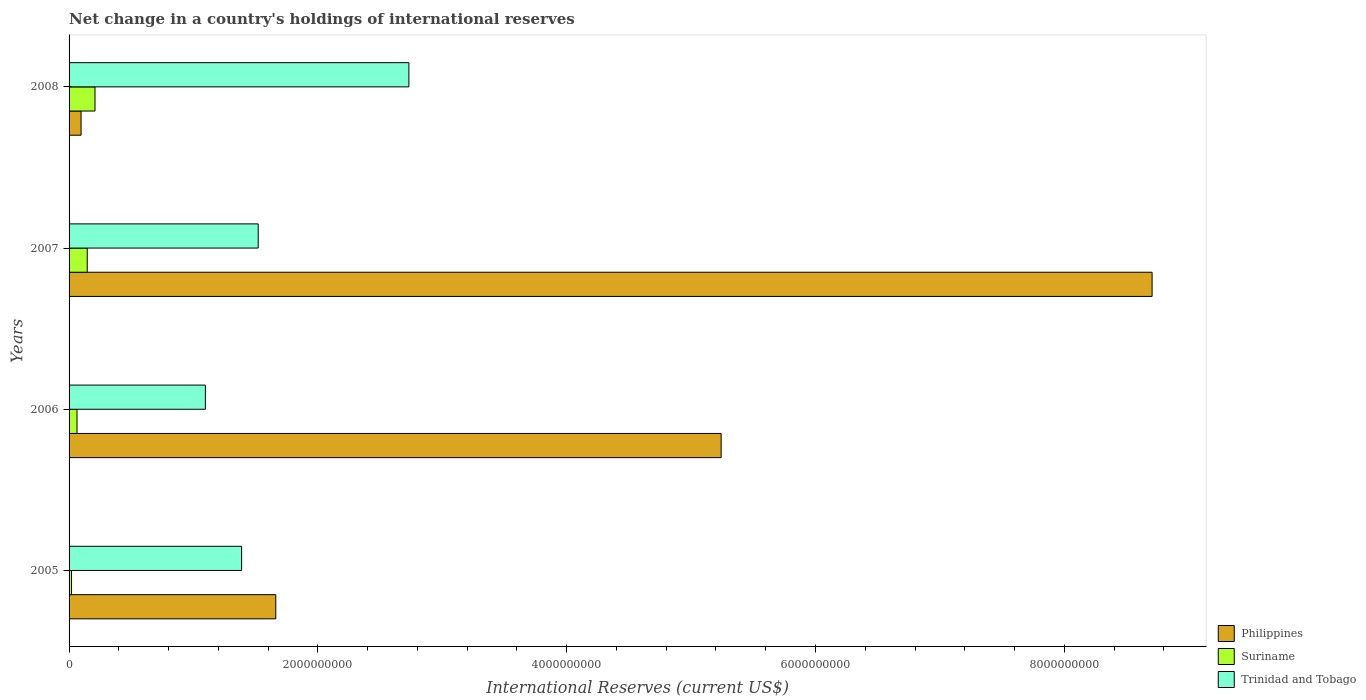How many different coloured bars are there?
Provide a short and direct response. 3. How many groups of bars are there?
Keep it short and to the point. 4. Are the number of bars per tick equal to the number of legend labels?
Offer a terse response. Yes. Are the number of bars on each tick of the Y-axis equal?
Provide a succinct answer. Yes. How many bars are there on the 1st tick from the bottom?
Keep it short and to the point. 3. What is the label of the 2nd group of bars from the top?
Your answer should be compact. 2007. In how many cases, is the number of bars for a given year not equal to the number of legend labels?
Give a very brief answer. 0. What is the international reserves in Suriname in 2007?
Keep it short and to the point. 1.46e+08. Across all years, what is the maximum international reserves in Philippines?
Your answer should be compact. 8.71e+09. Across all years, what is the minimum international reserves in Suriname?
Your answer should be very brief. 1.97e+07. In which year was the international reserves in Suriname maximum?
Provide a succinct answer. 2008. What is the total international reserves in Trinidad and Tobago in the graph?
Your response must be concise. 6.73e+09. What is the difference between the international reserves in Suriname in 2006 and that in 2007?
Your answer should be very brief. -8.22e+07. What is the difference between the international reserves in Suriname in 2005 and the international reserves in Trinidad and Tobago in 2008?
Ensure brevity in your answer.  -2.71e+09. What is the average international reserves in Suriname per year?
Ensure brevity in your answer.  1.10e+08. In the year 2006, what is the difference between the international reserves in Trinidad and Tobago and international reserves in Suriname?
Provide a short and direct response. 1.03e+09. In how many years, is the international reserves in Trinidad and Tobago greater than 5600000000 US$?
Offer a terse response. 0. What is the ratio of the international reserves in Philippines in 2007 to that in 2008?
Offer a terse response. 90.24. What is the difference between the highest and the second highest international reserves in Trinidad and Tobago?
Give a very brief answer. 1.21e+09. What is the difference between the highest and the lowest international reserves in Philippines?
Give a very brief answer. 8.61e+09. In how many years, is the international reserves in Philippines greater than the average international reserves in Philippines taken over all years?
Provide a short and direct response. 2. Is the sum of the international reserves in Suriname in 2005 and 2007 greater than the maximum international reserves in Philippines across all years?
Your answer should be very brief. No. What does the 1st bar from the top in 2007 represents?
Give a very brief answer. Trinidad and Tobago. Is it the case that in every year, the sum of the international reserves in Trinidad and Tobago and international reserves in Suriname is greater than the international reserves in Philippines?
Give a very brief answer. No. Are all the bars in the graph horizontal?
Make the answer very short. Yes. Are the values on the major ticks of X-axis written in scientific E-notation?
Ensure brevity in your answer.  No. Does the graph contain any zero values?
Provide a short and direct response. No. Does the graph contain grids?
Ensure brevity in your answer.  No. How are the legend labels stacked?
Keep it short and to the point. Vertical. What is the title of the graph?
Give a very brief answer. Net change in a country's holdings of international reserves. What is the label or title of the X-axis?
Ensure brevity in your answer.  International Reserves (current US$). What is the label or title of the Y-axis?
Make the answer very short. Years. What is the International Reserves (current US$) in Philippines in 2005?
Your answer should be compact. 1.66e+09. What is the International Reserves (current US$) of Suriname in 2005?
Provide a succinct answer. 1.97e+07. What is the International Reserves (current US$) of Trinidad and Tobago in 2005?
Your answer should be very brief. 1.39e+09. What is the International Reserves (current US$) in Philippines in 2006?
Offer a terse response. 5.24e+09. What is the International Reserves (current US$) of Suriname in 2006?
Offer a very short reply. 6.39e+07. What is the International Reserves (current US$) in Trinidad and Tobago in 2006?
Your response must be concise. 1.10e+09. What is the International Reserves (current US$) of Philippines in 2007?
Provide a succinct answer. 8.71e+09. What is the International Reserves (current US$) in Suriname in 2007?
Offer a very short reply. 1.46e+08. What is the International Reserves (current US$) of Trinidad and Tobago in 2007?
Make the answer very short. 1.52e+09. What is the International Reserves (current US$) in Philippines in 2008?
Your response must be concise. 9.65e+07. What is the International Reserves (current US$) of Suriname in 2008?
Your answer should be compact. 2.08e+08. What is the International Reserves (current US$) in Trinidad and Tobago in 2008?
Your answer should be compact. 2.73e+09. Across all years, what is the maximum International Reserves (current US$) of Philippines?
Offer a very short reply. 8.71e+09. Across all years, what is the maximum International Reserves (current US$) in Suriname?
Your answer should be very brief. 2.08e+08. Across all years, what is the maximum International Reserves (current US$) in Trinidad and Tobago?
Your answer should be very brief. 2.73e+09. Across all years, what is the minimum International Reserves (current US$) of Philippines?
Your answer should be compact. 9.65e+07. Across all years, what is the minimum International Reserves (current US$) of Suriname?
Provide a short and direct response. 1.97e+07. Across all years, what is the minimum International Reserves (current US$) of Trinidad and Tobago?
Your answer should be compact. 1.10e+09. What is the total International Reserves (current US$) in Philippines in the graph?
Keep it short and to the point. 1.57e+1. What is the total International Reserves (current US$) in Suriname in the graph?
Your answer should be very brief. 4.38e+08. What is the total International Reserves (current US$) of Trinidad and Tobago in the graph?
Make the answer very short. 6.73e+09. What is the difference between the International Reserves (current US$) in Philippines in 2005 and that in 2006?
Ensure brevity in your answer.  -3.58e+09. What is the difference between the International Reserves (current US$) of Suriname in 2005 and that in 2006?
Give a very brief answer. -4.42e+07. What is the difference between the International Reserves (current US$) of Trinidad and Tobago in 2005 and that in 2006?
Keep it short and to the point. 2.91e+08. What is the difference between the International Reserves (current US$) of Philippines in 2005 and that in 2007?
Your answer should be compact. -7.04e+09. What is the difference between the International Reserves (current US$) in Suriname in 2005 and that in 2007?
Offer a very short reply. -1.26e+08. What is the difference between the International Reserves (current US$) in Trinidad and Tobago in 2005 and that in 2007?
Provide a short and direct response. -1.33e+08. What is the difference between the International Reserves (current US$) of Philippines in 2005 and that in 2008?
Your answer should be very brief. 1.57e+09. What is the difference between the International Reserves (current US$) of Suriname in 2005 and that in 2008?
Ensure brevity in your answer.  -1.89e+08. What is the difference between the International Reserves (current US$) in Trinidad and Tobago in 2005 and that in 2008?
Offer a very short reply. -1.34e+09. What is the difference between the International Reserves (current US$) in Philippines in 2006 and that in 2007?
Ensure brevity in your answer.  -3.46e+09. What is the difference between the International Reserves (current US$) in Suriname in 2006 and that in 2007?
Offer a terse response. -8.22e+07. What is the difference between the International Reserves (current US$) of Trinidad and Tobago in 2006 and that in 2007?
Your response must be concise. -4.25e+08. What is the difference between the International Reserves (current US$) in Philippines in 2006 and that in 2008?
Offer a very short reply. 5.15e+09. What is the difference between the International Reserves (current US$) of Suriname in 2006 and that in 2008?
Offer a terse response. -1.44e+08. What is the difference between the International Reserves (current US$) in Trinidad and Tobago in 2006 and that in 2008?
Offer a very short reply. -1.64e+09. What is the difference between the International Reserves (current US$) in Philippines in 2007 and that in 2008?
Your answer should be compact. 8.61e+09. What is the difference between the International Reserves (current US$) in Suriname in 2007 and that in 2008?
Your answer should be compact. -6.23e+07. What is the difference between the International Reserves (current US$) in Trinidad and Tobago in 2007 and that in 2008?
Offer a terse response. -1.21e+09. What is the difference between the International Reserves (current US$) in Philippines in 2005 and the International Reserves (current US$) in Suriname in 2006?
Ensure brevity in your answer.  1.60e+09. What is the difference between the International Reserves (current US$) of Philippines in 2005 and the International Reserves (current US$) of Trinidad and Tobago in 2006?
Your response must be concise. 5.66e+08. What is the difference between the International Reserves (current US$) in Suriname in 2005 and the International Reserves (current US$) in Trinidad and Tobago in 2006?
Keep it short and to the point. -1.08e+09. What is the difference between the International Reserves (current US$) of Philippines in 2005 and the International Reserves (current US$) of Suriname in 2007?
Make the answer very short. 1.52e+09. What is the difference between the International Reserves (current US$) in Philippines in 2005 and the International Reserves (current US$) in Trinidad and Tobago in 2007?
Your answer should be very brief. 1.41e+08. What is the difference between the International Reserves (current US$) of Suriname in 2005 and the International Reserves (current US$) of Trinidad and Tobago in 2007?
Provide a short and direct response. -1.50e+09. What is the difference between the International Reserves (current US$) in Philippines in 2005 and the International Reserves (current US$) in Suriname in 2008?
Your answer should be compact. 1.45e+09. What is the difference between the International Reserves (current US$) of Philippines in 2005 and the International Reserves (current US$) of Trinidad and Tobago in 2008?
Your answer should be compact. -1.07e+09. What is the difference between the International Reserves (current US$) of Suriname in 2005 and the International Reserves (current US$) of Trinidad and Tobago in 2008?
Your answer should be very brief. -2.71e+09. What is the difference between the International Reserves (current US$) in Philippines in 2006 and the International Reserves (current US$) in Suriname in 2007?
Offer a very short reply. 5.10e+09. What is the difference between the International Reserves (current US$) of Philippines in 2006 and the International Reserves (current US$) of Trinidad and Tobago in 2007?
Provide a succinct answer. 3.72e+09. What is the difference between the International Reserves (current US$) in Suriname in 2006 and the International Reserves (current US$) in Trinidad and Tobago in 2007?
Provide a short and direct response. -1.46e+09. What is the difference between the International Reserves (current US$) in Philippines in 2006 and the International Reserves (current US$) in Suriname in 2008?
Offer a terse response. 5.03e+09. What is the difference between the International Reserves (current US$) in Philippines in 2006 and the International Reserves (current US$) in Trinidad and Tobago in 2008?
Make the answer very short. 2.51e+09. What is the difference between the International Reserves (current US$) of Suriname in 2006 and the International Reserves (current US$) of Trinidad and Tobago in 2008?
Make the answer very short. -2.67e+09. What is the difference between the International Reserves (current US$) of Philippines in 2007 and the International Reserves (current US$) of Suriname in 2008?
Ensure brevity in your answer.  8.50e+09. What is the difference between the International Reserves (current US$) in Philippines in 2007 and the International Reserves (current US$) in Trinidad and Tobago in 2008?
Your response must be concise. 5.97e+09. What is the difference between the International Reserves (current US$) in Suriname in 2007 and the International Reserves (current US$) in Trinidad and Tobago in 2008?
Offer a very short reply. -2.59e+09. What is the average International Reserves (current US$) of Philippines per year?
Provide a succinct answer. 3.93e+09. What is the average International Reserves (current US$) of Suriname per year?
Provide a succinct answer. 1.10e+08. What is the average International Reserves (current US$) in Trinidad and Tobago per year?
Provide a short and direct response. 1.68e+09. In the year 2005, what is the difference between the International Reserves (current US$) in Philippines and International Reserves (current US$) in Suriname?
Keep it short and to the point. 1.64e+09. In the year 2005, what is the difference between the International Reserves (current US$) of Philippines and International Reserves (current US$) of Trinidad and Tobago?
Keep it short and to the point. 2.75e+08. In the year 2005, what is the difference between the International Reserves (current US$) of Suriname and International Reserves (current US$) of Trinidad and Tobago?
Offer a terse response. -1.37e+09. In the year 2006, what is the difference between the International Reserves (current US$) in Philippines and International Reserves (current US$) in Suriname?
Provide a short and direct response. 5.18e+09. In the year 2006, what is the difference between the International Reserves (current US$) of Philippines and International Reserves (current US$) of Trinidad and Tobago?
Provide a short and direct response. 4.15e+09. In the year 2006, what is the difference between the International Reserves (current US$) in Suriname and International Reserves (current US$) in Trinidad and Tobago?
Provide a short and direct response. -1.03e+09. In the year 2007, what is the difference between the International Reserves (current US$) of Philippines and International Reserves (current US$) of Suriname?
Make the answer very short. 8.56e+09. In the year 2007, what is the difference between the International Reserves (current US$) in Philippines and International Reserves (current US$) in Trinidad and Tobago?
Your answer should be compact. 7.19e+09. In the year 2007, what is the difference between the International Reserves (current US$) of Suriname and International Reserves (current US$) of Trinidad and Tobago?
Your response must be concise. -1.37e+09. In the year 2008, what is the difference between the International Reserves (current US$) of Philippines and International Reserves (current US$) of Suriname?
Give a very brief answer. -1.12e+08. In the year 2008, what is the difference between the International Reserves (current US$) in Philippines and International Reserves (current US$) in Trinidad and Tobago?
Keep it short and to the point. -2.64e+09. In the year 2008, what is the difference between the International Reserves (current US$) of Suriname and International Reserves (current US$) of Trinidad and Tobago?
Your response must be concise. -2.52e+09. What is the ratio of the International Reserves (current US$) of Philippines in 2005 to that in 2006?
Your answer should be very brief. 0.32. What is the ratio of the International Reserves (current US$) of Suriname in 2005 to that in 2006?
Keep it short and to the point. 0.31. What is the ratio of the International Reserves (current US$) of Trinidad and Tobago in 2005 to that in 2006?
Your answer should be very brief. 1.27. What is the ratio of the International Reserves (current US$) of Philippines in 2005 to that in 2007?
Your answer should be compact. 0.19. What is the ratio of the International Reserves (current US$) of Suriname in 2005 to that in 2007?
Make the answer very short. 0.13. What is the ratio of the International Reserves (current US$) in Trinidad and Tobago in 2005 to that in 2007?
Offer a very short reply. 0.91. What is the ratio of the International Reserves (current US$) of Philippines in 2005 to that in 2008?
Your answer should be compact. 17.22. What is the ratio of the International Reserves (current US$) of Suriname in 2005 to that in 2008?
Keep it short and to the point. 0.09. What is the ratio of the International Reserves (current US$) in Trinidad and Tobago in 2005 to that in 2008?
Give a very brief answer. 0.51. What is the ratio of the International Reserves (current US$) of Philippines in 2006 to that in 2007?
Make the answer very short. 0.6. What is the ratio of the International Reserves (current US$) of Suriname in 2006 to that in 2007?
Offer a terse response. 0.44. What is the ratio of the International Reserves (current US$) of Trinidad and Tobago in 2006 to that in 2007?
Your answer should be compact. 0.72. What is the ratio of the International Reserves (current US$) in Philippines in 2006 to that in 2008?
Your answer should be very brief. 54.33. What is the ratio of the International Reserves (current US$) in Suriname in 2006 to that in 2008?
Offer a terse response. 0.31. What is the ratio of the International Reserves (current US$) of Trinidad and Tobago in 2006 to that in 2008?
Offer a terse response. 0.4. What is the ratio of the International Reserves (current US$) in Philippines in 2007 to that in 2008?
Your answer should be very brief. 90.24. What is the ratio of the International Reserves (current US$) in Suriname in 2007 to that in 2008?
Make the answer very short. 0.7. What is the ratio of the International Reserves (current US$) of Trinidad and Tobago in 2007 to that in 2008?
Offer a very short reply. 0.56. What is the difference between the highest and the second highest International Reserves (current US$) of Philippines?
Provide a succinct answer. 3.46e+09. What is the difference between the highest and the second highest International Reserves (current US$) in Suriname?
Provide a short and direct response. 6.23e+07. What is the difference between the highest and the second highest International Reserves (current US$) of Trinidad and Tobago?
Keep it short and to the point. 1.21e+09. What is the difference between the highest and the lowest International Reserves (current US$) of Philippines?
Offer a terse response. 8.61e+09. What is the difference between the highest and the lowest International Reserves (current US$) in Suriname?
Offer a very short reply. 1.89e+08. What is the difference between the highest and the lowest International Reserves (current US$) in Trinidad and Tobago?
Offer a very short reply. 1.64e+09. 